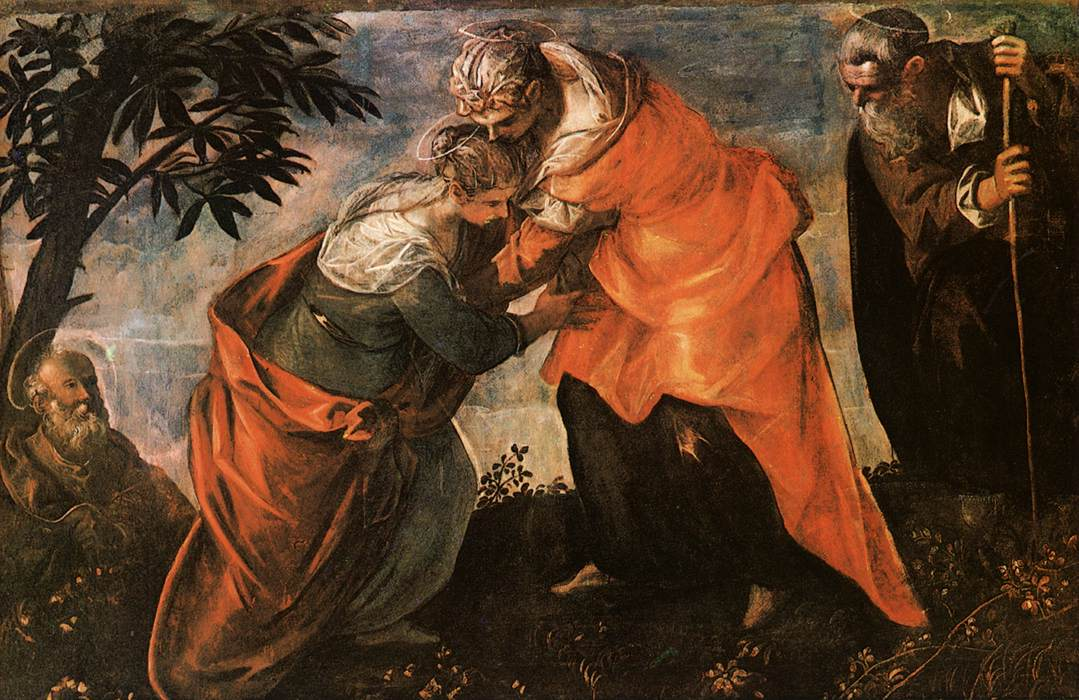Imagine if this scene was set in a mythical world, what mythological elements could enhance it? In a mythical world, the scene could be set in an enchanted forest, where the trees have golden leaves whispering ancient prophecies. Here, Mary and Elizabeth could be surrounded by mythical creatures like gentle centaurs, wise talking owls, and ethereal fairies sprinkling blessings. The robes they wear might shimmer with magical threads, a sign of their divine roles. The garden itself could be alive with luminescent flowers that bloom only in the presence of true divinity, and a serene, magical stream could flow, whispering celestial secrets. The air would be thick with a tangible aura of magic, as if the entire forest rejoiced in their meeting, keeping time with a gentle, mystical melody that reverberates with timeless echoes of divine prophecy and joy. 